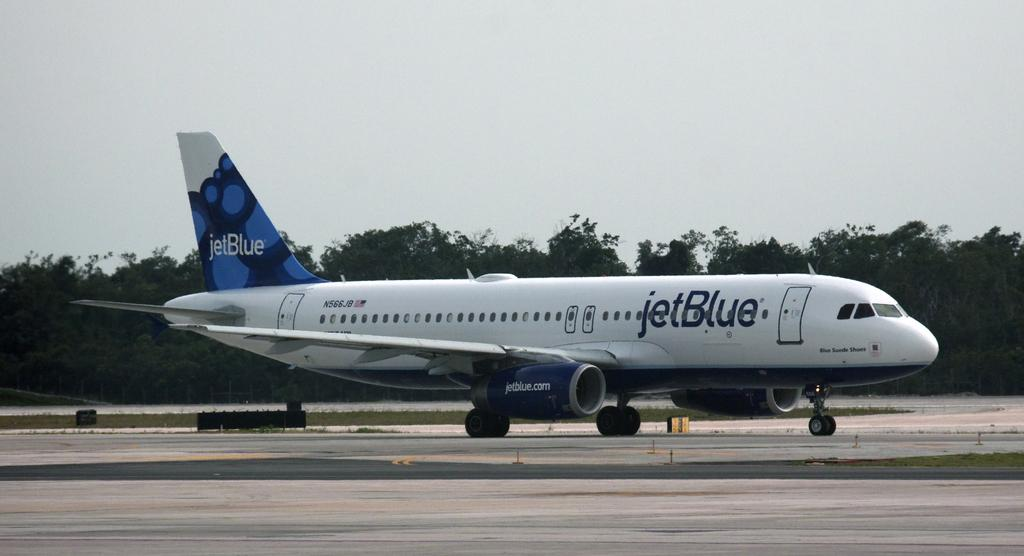What type of vehicle is in the image? There is a passenger plane in the image. Where is the plane located? The plane is on a runway. What can be seen in the background of the image? There are trees, plants, and grass in the background of the image. What is visible at the top of the image? The sky is visible at the top of the image, and clouds are present in the sky. Where is the nearest shop to the plane in the image? There is no shop present in the image; it only shows a passenger plane on a runway with a background of trees, plants, grass, and the sky. 